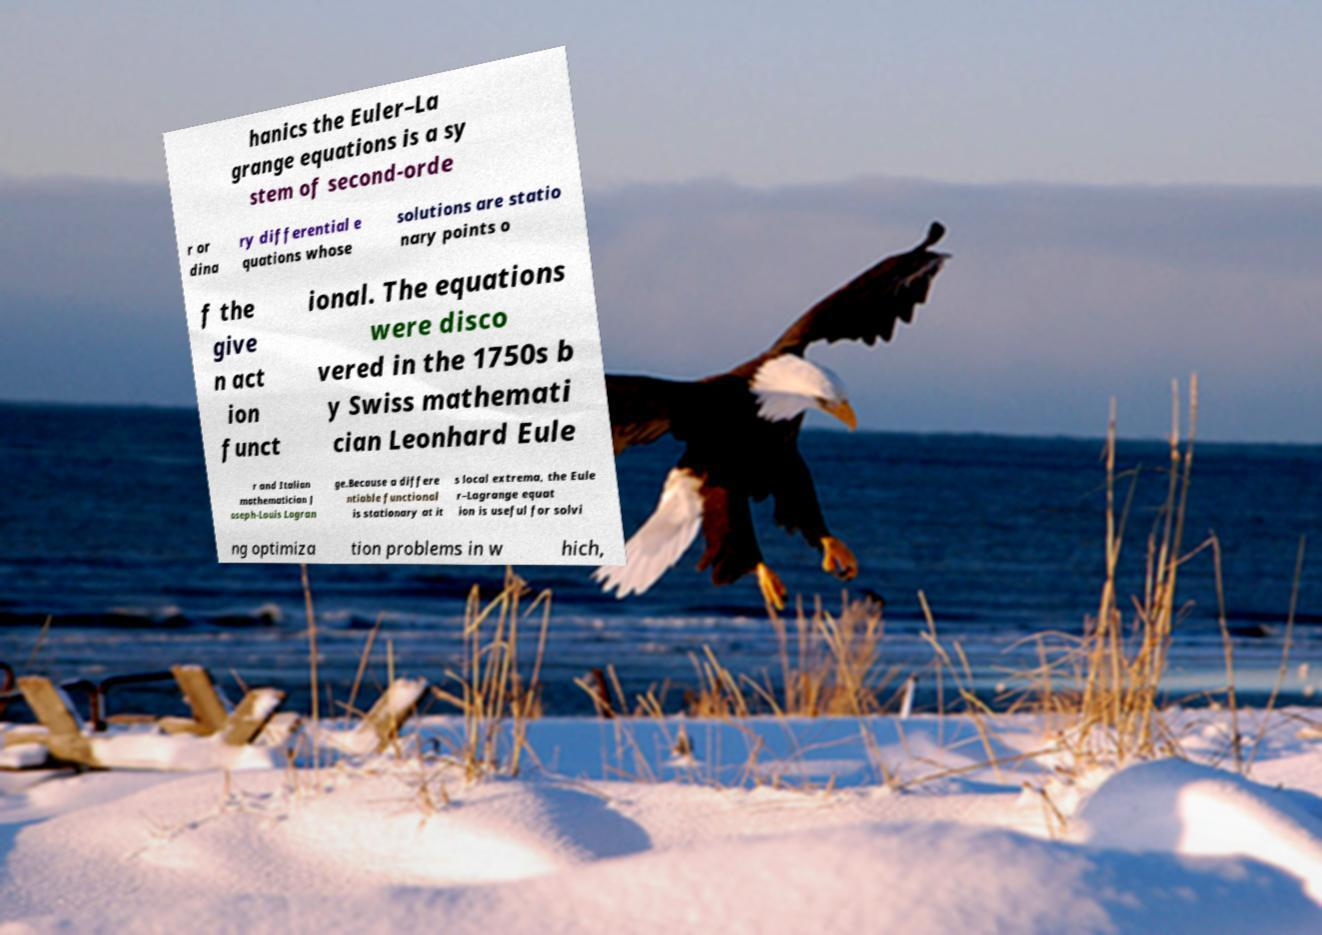What messages or text are displayed in this image? I need them in a readable, typed format. hanics the Euler–La grange equations is a sy stem of second-orde r or dina ry differential e quations whose solutions are statio nary points o f the give n act ion funct ional. The equations were disco vered in the 1750s b y Swiss mathemati cian Leonhard Eule r and Italian mathematician J oseph-Louis Lagran ge.Because a differe ntiable functional is stationary at it s local extrema, the Eule r–Lagrange equat ion is useful for solvi ng optimiza tion problems in w hich, 